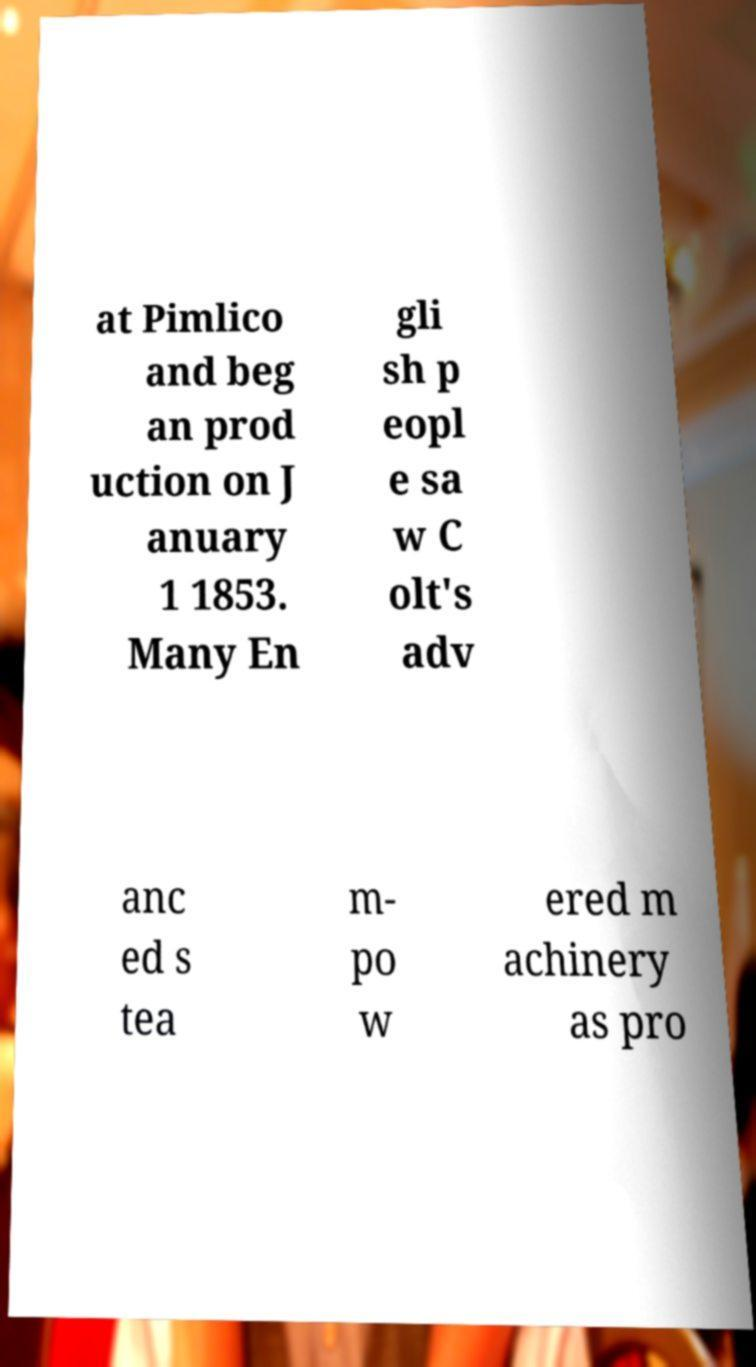Can you accurately transcribe the text from the provided image for me? at Pimlico and beg an prod uction on J anuary 1 1853. Many En gli sh p eopl e sa w C olt's adv anc ed s tea m- po w ered m achinery as pro 